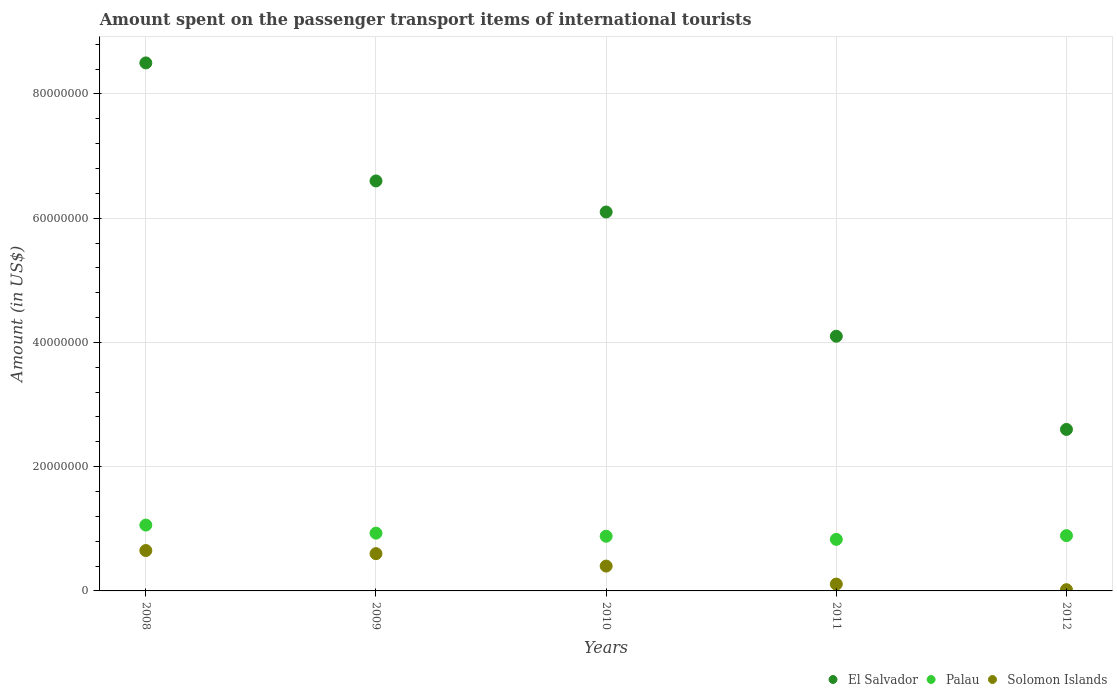How many different coloured dotlines are there?
Your answer should be very brief. 3. What is the amount spent on the passenger transport items of international tourists in El Salvador in 2011?
Ensure brevity in your answer.  4.10e+07. Across all years, what is the maximum amount spent on the passenger transport items of international tourists in Palau?
Ensure brevity in your answer.  1.06e+07. Across all years, what is the minimum amount spent on the passenger transport items of international tourists in El Salvador?
Provide a short and direct response. 2.60e+07. In which year was the amount spent on the passenger transport items of international tourists in El Salvador maximum?
Ensure brevity in your answer.  2008. In which year was the amount spent on the passenger transport items of international tourists in Palau minimum?
Give a very brief answer. 2011. What is the total amount spent on the passenger transport items of international tourists in El Salvador in the graph?
Keep it short and to the point. 2.79e+08. What is the difference between the amount spent on the passenger transport items of international tourists in Solomon Islands in 2009 and that in 2011?
Make the answer very short. 4.90e+06. What is the difference between the amount spent on the passenger transport items of international tourists in El Salvador in 2012 and the amount spent on the passenger transport items of international tourists in Palau in 2008?
Offer a terse response. 1.54e+07. What is the average amount spent on the passenger transport items of international tourists in Solomon Islands per year?
Keep it short and to the point. 3.56e+06. In the year 2012, what is the difference between the amount spent on the passenger transport items of international tourists in Palau and amount spent on the passenger transport items of international tourists in Solomon Islands?
Keep it short and to the point. 8.70e+06. In how many years, is the amount spent on the passenger transport items of international tourists in El Salvador greater than 40000000 US$?
Offer a terse response. 4. What is the ratio of the amount spent on the passenger transport items of international tourists in El Salvador in 2010 to that in 2011?
Offer a terse response. 1.49. What is the difference between the highest and the second highest amount spent on the passenger transport items of international tourists in El Salvador?
Provide a short and direct response. 1.90e+07. What is the difference between the highest and the lowest amount spent on the passenger transport items of international tourists in Palau?
Ensure brevity in your answer.  2.30e+06. Is the sum of the amount spent on the passenger transport items of international tourists in Palau in 2009 and 2012 greater than the maximum amount spent on the passenger transport items of international tourists in Solomon Islands across all years?
Provide a short and direct response. Yes. Is the amount spent on the passenger transport items of international tourists in El Salvador strictly greater than the amount spent on the passenger transport items of international tourists in Solomon Islands over the years?
Your answer should be compact. Yes. How many years are there in the graph?
Give a very brief answer. 5. Does the graph contain grids?
Provide a short and direct response. Yes. Where does the legend appear in the graph?
Give a very brief answer. Bottom right. How are the legend labels stacked?
Give a very brief answer. Horizontal. What is the title of the graph?
Keep it short and to the point. Amount spent on the passenger transport items of international tourists. Does "Maldives" appear as one of the legend labels in the graph?
Provide a succinct answer. No. What is the Amount (in US$) in El Salvador in 2008?
Keep it short and to the point. 8.50e+07. What is the Amount (in US$) of Palau in 2008?
Provide a short and direct response. 1.06e+07. What is the Amount (in US$) in Solomon Islands in 2008?
Keep it short and to the point. 6.50e+06. What is the Amount (in US$) in El Salvador in 2009?
Provide a succinct answer. 6.60e+07. What is the Amount (in US$) of Palau in 2009?
Your response must be concise. 9.30e+06. What is the Amount (in US$) of El Salvador in 2010?
Provide a succinct answer. 6.10e+07. What is the Amount (in US$) in Palau in 2010?
Your response must be concise. 8.80e+06. What is the Amount (in US$) of El Salvador in 2011?
Offer a terse response. 4.10e+07. What is the Amount (in US$) of Palau in 2011?
Your response must be concise. 8.30e+06. What is the Amount (in US$) of Solomon Islands in 2011?
Provide a succinct answer. 1.10e+06. What is the Amount (in US$) of El Salvador in 2012?
Ensure brevity in your answer.  2.60e+07. What is the Amount (in US$) of Palau in 2012?
Make the answer very short. 8.90e+06. Across all years, what is the maximum Amount (in US$) in El Salvador?
Give a very brief answer. 8.50e+07. Across all years, what is the maximum Amount (in US$) in Palau?
Ensure brevity in your answer.  1.06e+07. Across all years, what is the maximum Amount (in US$) in Solomon Islands?
Ensure brevity in your answer.  6.50e+06. Across all years, what is the minimum Amount (in US$) of El Salvador?
Provide a succinct answer. 2.60e+07. Across all years, what is the minimum Amount (in US$) in Palau?
Provide a succinct answer. 8.30e+06. What is the total Amount (in US$) in El Salvador in the graph?
Give a very brief answer. 2.79e+08. What is the total Amount (in US$) in Palau in the graph?
Your answer should be very brief. 4.59e+07. What is the total Amount (in US$) of Solomon Islands in the graph?
Provide a short and direct response. 1.78e+07. What is the difference between the Amount (in US$) in El Salvador in 2008 and that in 2009?
Make the answer very short. 1.90e+07. What is the difference between the Amount (in US$) in Palau in 2008 and that in 2009?
Ensure brevity in your answer.  1.30e+06. What is the difference between the Amount (in US$) of Solomon Islands in 2008 and that in 2009?
Offer a terse response. 5.00e+05. What is the difference between the Amount (in US$) in El Salvador in 2008 and that in 2010?
Your answer should be compact. 2.40e+07. What is the difference between the Amount (in US$) in Palau in 2008 and that in 2010?
Your answer should be compact. 1.80e+06. What is the difference between the Amount (in US$) of Solomon Islands in 2008 and that in 2010?
Provide a succinct answer. 2.50e+06. What is the difference between the Amount (in US$) in El Salvador in 2008 and that in 2011?
Offer a very short reply. 4.40e+07. What is the difference between the Amount (in US$) of Palau in 2008 and that in 2011?
Give a very brief answer. 2.30e+06. What is the difference between the Amount (in US$) of Solomon Islands in 2008 and that in 2011?
Provide a succinct answer. 5.40e+06. What is the difference between the Amount (in US$) of El Salvador in 2008 and that in 2012?
Provide a short and direct response. 5.90e+07. What is the difference between the Amount (in US$) in Palau in 2008 and that in 2012?
Your answer should be very brief. 1.70e+06. What is the difference between the Amount (in US$) in Solomon Islands in 2008 and that in 2012?
Your answer should be compact. 6.30e+06. What is the difference between the Amount (in US$) in El Salvador in 2009 and that in 2010?
Provide a short and direct response. 5.00e+06. What is the difference between the Amount (in US$) in Solomon Islands in 2009 and that in 2010?
Provide a succinct answer. 2.00e+06. What is the difference between the Amount (in US$) of El Salvador in 2009 and that in 2011?
Provide a short and direct response. 2.50e+07. What is the difference between the Amount (in US$) in Palau in 2009 and that in 2011?
Keep it short and to the point. 1.00e+06. What is the difference between the Amount (in US$) of Solomon Islands in 2009 and that in 2011?
Provide a short and direct response. 4.90e+06. What is the difference between the Amount (in US$) of El Salvador in 2009 and that in 2012?
Keep it short and to the point. 4.00e+07. What is the difference between the Amount (in US$) of Palau in 2009 and that in 2012?
Provide a short and direct response. 4.00e+05. What is the difference between the Amount (in US$) in Solomon Islands in 2009 and that in 2012?
Your answer should be very brief. 5.80e+06. What is the difference between the Amount (in US$) of El Salvador in 2010 and that in 2011?
Your answer should be compact. 2.00e+07. What is the difference between the Amount (in US$) in Solomon Islands in 2010 and that in 2011?
Provide a succinct answer. 2.90e+06. What is the difference between the Amount (in US$) in El Salvador in 2010 and that in 2012?
Your response must be concise. 3.50e+07. What is the difference between the Amount (in US$) of Palau in 2010 and that in 2012?
Provide a short and direct response. -1.00e+05. What is the difference between the Amount (in US$) of Solomon Islands in 2010 and that in 2012?
Give a very brief answer. 3.80e+06. What is the difference between the Amount (in US$) of El Salvador in 2011 and that in 2012?
Provide a succinct answer. 1.50e+07. What is the difference between the Amount (in US$) in Palau in 2011 and that in 2012?
Your answer should be compact. -6.00e+05. What is the difference between the Amount (in US$) in El Salvador in 2008 and the Amount (in US$) in Palau in 2009?
Offer a terse response. 7.57e+07. What is the difference between the Amount (in US$) of El Salvador in 2008 and the Amount (in US$) of Solomon Islands in 2009?
Your answer should be very brief. 7.90e+07. What is the difference between the Amount (in US$) in Palau in 2008 and the Amount (in US$) in Solomon Islands in 2009?
Provide a short and direct response. 4.60e+06. What is the difference between the Amount (in US$) of El Salvador in 2008 and the Amount (in US$) of Palau in 2010?
Keep it short and to the point. 7.62e+07. What is the difference between the Amount (in US$) in El Salvador in 2008 and the Amount (in US$) in Solomon Islands in 2010?
Provide a succinct answer. 8.10e+07. What is the difference between the Amount (in US$) in Palau in 2008 and the Amount (in US$) in Solomon Islands in 2010?
Make the answer very short. 6.60e+06. What is the difference between the Amount (in US$) of El Salvador in 2008 and the Amount (in US$) of Palau in 2011?
Keep it short and to the point. 7.67e+07. What is the difference between the Amount (in US$) in El Salvador in 2008 and the Amount (in US$) in Solomon Islands in 2011?
Offer a very short reply. 8.39e+07. What is the difference between the Amount (in US$) in Palau in 2008 and the Amount (in US$) in Solomon Islands in 2011?
Keep it short and to the point. 9.50e+06. What is the difference between the Amount (in US$) of El Salvador in 2008 and the Amount (in US$) of Palau in 2012?
Provide a succinct answer. 7.61e+07. What is the difference between the Amount (in US$) in El Salvador in 2008 and the Amount (in US$) in Solomon Islands in 2012?
Keep it short and to the point. 8.48e+07. What is the difference between the Amount (in US$) of Palau in 2008 and the Amount (in US$) of Solomon Islands in 2012?
Offer a terse response. 1.04e+07. What is the difference between the Amount (in US$) of El Salvador in 2009 and the Amount (in US$) of Palau in 2010?
Your answer should be compact. 5.72e+07. What is the difference between the Amount (in US$) in El Salvador in 2009 and the Amount (in US$) in Solomon Islands in 2010?
Your answer should be very brief. 6.20e+07. What is the difference between the Amount (in US$) in Palau in 2009 and the Amount (in US$) in Solomon Islands in 2010?
Provide a succinct answer. 5.30e+06. What is the difference between the Amount (in US$) of El Salvador in 2009 and the Amount (in US$) of Palau in 2011?
Offer a very short reply. 5.77e+07. What is the difference between the Amount (in US$) of El Salvador in 2009 and the Amount (in US$) of Solomon Islands in 2011?
Keep it short and to the point. 6.49e+07. What is the difference between the Amount (in US$) of Palau in 2009 and the Amount (in US$) of Solomon Islands in 2011?
Keep it short and to the point. 8.20e+06. What is the difference between the Amount (in US$) in El Salvador in 2009 and the Amount (in US$) in Palau in 2012?
Keep it short and to the point. 5.71e+07. What is the difference between the Amount (in US$) of El Salvador in 2009 and the Amount (in US$) of Solomon Islands in 2012?
Offer a terse response. 6.58e+07. What is the difference between the Amount (in US$) of Palau in 2009 and the Amount (in US$) of Solomon Islands in 2012?
Make the answer very short. 9.10e+06. What is the difference between the Amount (in US$) in El Salvador in 2010 and the Amount (in US$) in Palau in 2011?
Your answer should be very brief. 5.27e+07. What is the difference between the Amount (in US$) in El Salvador in 2010 and the Amount (in US$) in Solomon Islands in 2011?
Offer a terse response. 5.99e+07. What is the difference between the Amount (in US$) of Palau in 2010 and the Amount (in US$) of Solomon Islands in 2011?
Make the answer very short. 7.70e+06. What is the difference between the Amount (in US$) of El Salvador in 2010 and the Amount (in US$) of Palau in 2012?
Keep it short and to the point. 5.21e+07. What is the difference between the Amount (in US$) of El Salvador in 2010 and the Amount (in US$) of Solomon Islands in 2012?
Keep it short and to the point. 6.08e+07. What is the difference between the Amount (in US$) of Palau in 2010 and the Amount (in US$) of Solomon Islands in 2012?
Ensure brevity in your answer.  8.60e+06. What is the difference between the Amount (in US$) in El Salvador in 2011 and the Amount (in US$) in Palau in 2012?
Make the answer very short. 3.21e+07. What is the difference between the Amount (in US$) of El Salvador in 2011 and the Amount (in US$) of Solomon Islands in 2012?
Offer a very short reply. 4.08e+07. What is the difference between the Amount (in US$) in Palau in 2011 and the Amount (in US$) in Solomon Islands in 2012?
Your answer should be compact. 8.10e+06. What is the average Amount (in US$) in El Salvador per year?
Provide a succinct answer. 5.58e+07. What is the average Amount (in US$) in Palau per year?
Provide a short and direct response. 9.18e+06. What is the average Amount (in US$) in Solomon Islands per year?
Ensure brevity in your answer.  3.56e+06. In the year 2008, what is the difference between the Amount (in US$) in El Salvador and Amount (in US$) in Palau?
Provide a short and direct response. 7.44e+07. In the year 2008, what is the difference between the Amount (in US$) in El Salvador and Amount (in US$) in Solomon Islands?
Offer a very short reply. 7.85e+07. In the year 2008, what is the difference between the Amount (in US$) in Palau and Amount (in US$) in Solomon Islands?
Provide a succinct answer. 4.10e+06. In the year 2009, what is the difference between the Amount (in US$) in El Salvador and Amount (in US$) in Palau?
Provide a succinct answer. 5.67e+07. In the year 2009, what is the difference between the Amount (in US$) of El Salvador and Amount (in US$) of Solomon Islands?
Your answer should be compact. 6.00e+07. In the year 2009, what is the difference between the Amount (in US$) in Palau and Amount (in US$) in Solomon Islands?
Make the answer very short. 3.30e+06. In the year 2010, what is the difference between the Amount (in US$) of El Salvador and Amount (in US$) of Palau?
Ensure brevity in your answer.  5.22e+07. In the year 2010, what is the difference between the Amount (in US$) of El Salvador and Amount (in US$) of Solomon Islands?
Your response must be concise. 5.70e+07. In the year 2010, what is the difference between the Amount (in US$) of Palau and Amount (in US$) of Solomon Islands?
Offer a very short reply. 4.80e+06. In the year 2011, what is the difference between the Amount (in US$) in El Salvador and Amount (in US$) in Palau?
Your response must be concise. 3.27e+07. In the year 2011, what is the difference between the Amount (in US$) in El Salvador and Amount (in US$) in Solomon Islands?
Give a very brief answer. 3.99e+07. In the year 2011, what is the difference between the Amount (in US$) of Palau and Amount (in US$) of Solomon Islands?
Your answer should be very brief. 7.20e+06. In the year 2012, what is the difference between the Amount (in US$) of El Salvador and Amount (in US$) of Palau?
Provide a succinct answer. 1.71e+07. In the year 2012, what is the difference between the Amount (in US$) in El Salvador and Amount (in US$) in Solomon Islands?
Make the answer very short. 2.58e+07. In the year 2012, what is the difference between the Amount (in US$) of Palau and Amount (in US$) of Solomon Islands?
Give a very brief answer. 8.70e+06. What is the ratio of the Amount (in US$) of El Salvador in 2008 to that in 2009?
Ensure brevity in your answer.  1.29. What is the ratio of the Amount (in US$) in Palau in 2008 to that in 2009?
Ensure brevity in your answer.  1.14. What is the ratio of the Amount (in US$) of El Salvador in 2008 to that in 2010?
Your answer should be compact. 1.39. What is the ratio of the Amount (in US$) in Palau in 2008 to that in 2010?
Offer a very short reply. 1.2. What is the ratio of the Amount (in US$) in Solomon Islands in 2008 to that in 2010?
Keep it short and to the point. 1.62. What is the ratio of the Amount (in US$) in El Salvador in 2008 to that in 2011?
Ensure brevity in your answer.  2.07. What is the ratio of the Amount (in US$) of Palau in 2008 to that in 2011?
Offer a very short reply. 1.28. What is the ratio of the Amount (in US$) in Solomon Islands in 2008 to that in 2011?
Your response must be concise. 5.91. What is the ratio of the Amount (in US$) in El Salvador in 2008 to that in 2012?
Offer a terse response. 3.27. What is the ratio of the Amount (in US$) of Palau in 2008 to that in 2012?
Your response must be concise. 1.19. What is the ratio of the Amount (in US$) of Solomon Islands in 2008 to that in 2012?
Offer a very short reply. 32.5. What is the ratio of the Amount (in US$) of El Salvador in 2009 to that in 2010?
Provide a short and direct response. 1.08. What is the ratio of the Amount (in US$) in Palau in 2009 to that in 2010?
Make the answer very short. 1.06. What is the ratio of the Amount (in US$) in Solomon Islands in 2009 to that in 2010?
Keep it short and to the point. 1.5. What is the ratio of the Amount (in US$) in El Salvador in 2009 to that in 2011?
Give a very brief answer. 1.61. What is the ratio of the Amount (in US$) of Palau in 2009 to that in 2011?
Your response must be concise. 1.12. What is the ratio of the Amount (in US$) of Solomon Islands in 2009 to that in 2011?
Offer a terse response. 5.45. What is the ratio of the Amount (in US$) in El Salvador in 2009 to that in 2012?
Your answer should be very brief. 2.54. What is the ratio of the Amount (in US$) in Palau in 2009 to that in 2012?
Offer a very short reply. 1.04. What is the ratio of the Amount (in US$) of Solomon Islands in 2009 to that in 2012?
Provide a short and direct response. 30. What is the ratio of the Amount (in US$) of El Salvador in 2010 to that in 2011?
Keep it short and to the point. 1.49. What is the ratio of the Amount (in US$) of Palau in 2010 to that in 2011?
Your response must be concise. 1.06. What is the ratio of the Amount (in US$) of Solomon Islands in 2010 to that in 2011?
Your answer should be very brief. 3.64. What is the ratio of the Amount (in US$) in El Salvador in 2010 to that in 2012?
Your answer should be compact. 2.35. What is the ratio of the Amount (in US$) in Solomon Islands in 2010 to that in 2012?
Make the answer very short. 20. What is the ratio of the Amount (in US$) of El Salvador in 2011 to that in 2012?
Give a very brief answer. 1.58. What is the ratio of the Amount (in US$) in Palau in 2011 to that in 2012?
Offer a very short reply. 0.93. What is the difference between the highest and the second highest Amount (in US$) in El Salvador?
Make the answer very short. 1.90e+07. What is the difference between the highest and the second highest Amount (in US$) in Palau?
Keep it short and to the point. 1.30e+06. What is the difference between the highest and the lowest Amount (in US$) in El Salvador?
Make the answer very short. 5.90e+07. What is the difference between the highest and the lowest Amount (in US$) of Palau?
Provide a short and direct response. 2.30e+06. What is the difference between the highest and the lowest Amount (in US$) in Solomon Islands?
Provide a succinct answer. 6.30e+06. 